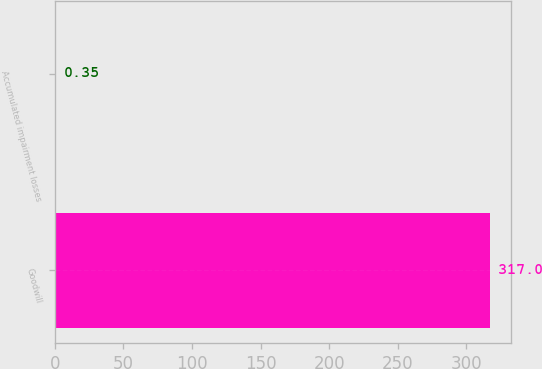<chart> <loc_0><loc_0><loc_500><loc_500><bar_chart><fcel>Goodwill<fcel>Accumulated impairment losses<nl><fcel>317<fcel>0.35<nl></chart> 